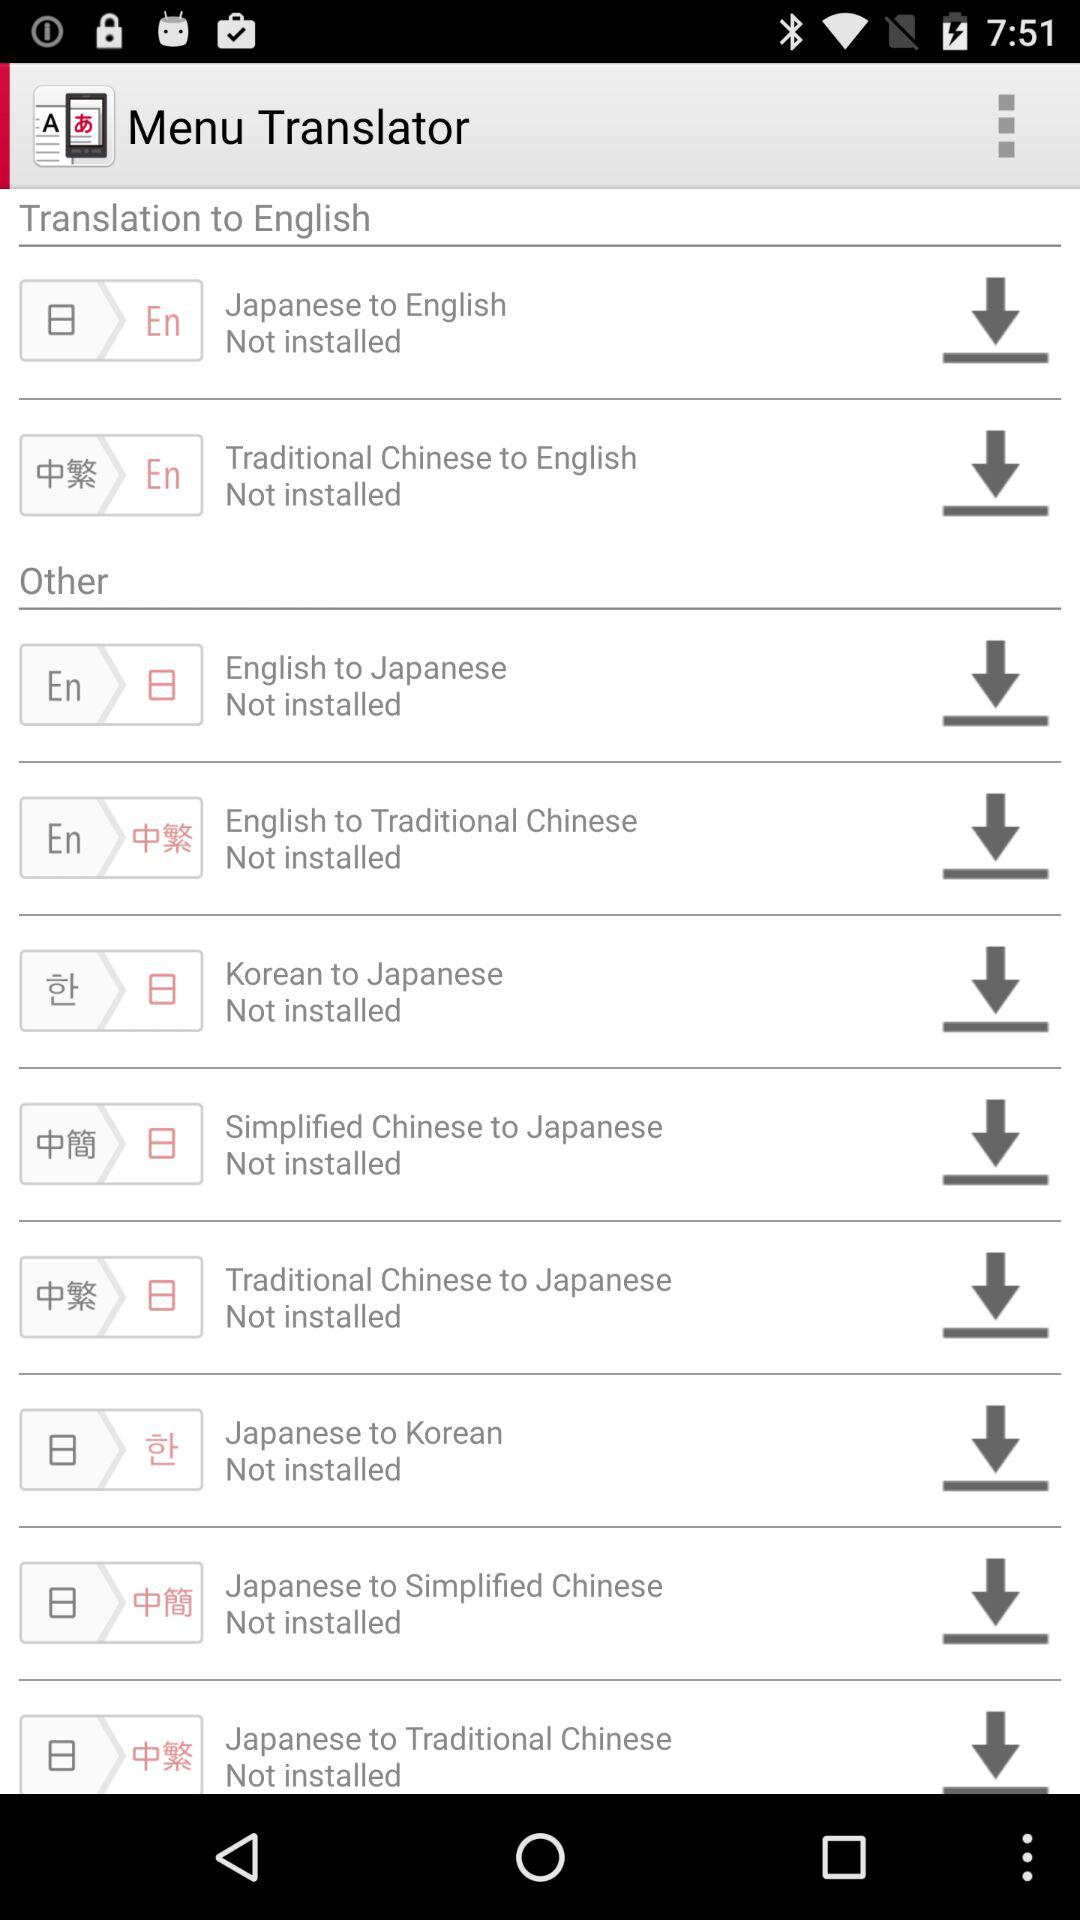How many languages are available for translation to English?
Answer the question using a single word or phrase. 2 